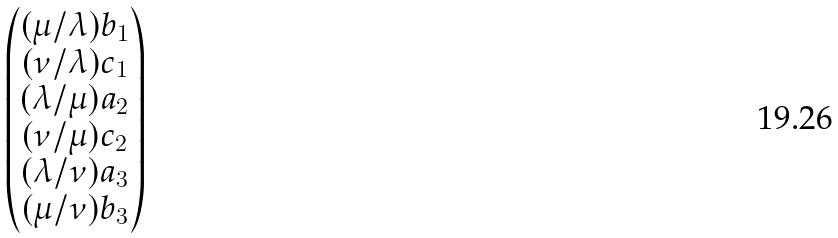<formula> <loc_0><loc_0><loc_500><loc_500>\begin{pmatrix} ( \mu / \lambda ) b _ { 1 } \\ ( \nu / \lambda ) c _ { 1 } \\ ( \lambda / \mu ) a _ { 2 } \\ ( \nu / \mu ) c _ { 2 } \\ ( \lambda / \nu ) a _ { 3 } \\ ( \mu / \nu ) b _ { 3 } \end{pmatrix}</formula> 